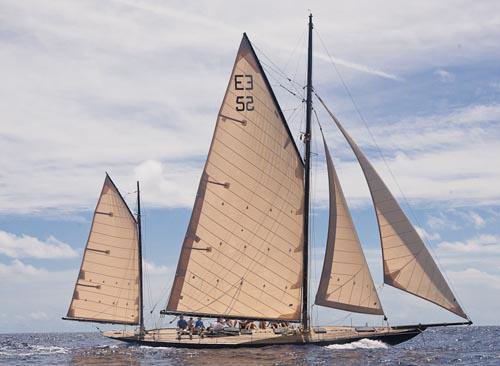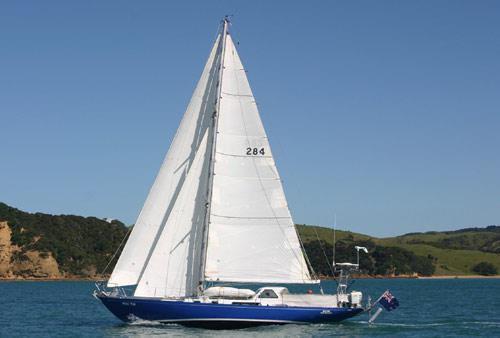The first image is the image on the left, the second image is the image on the right. Examine the images to the left and right. Is the description "There is land in the background of the image on the right." accurate? Answer yes or no. Yes. 